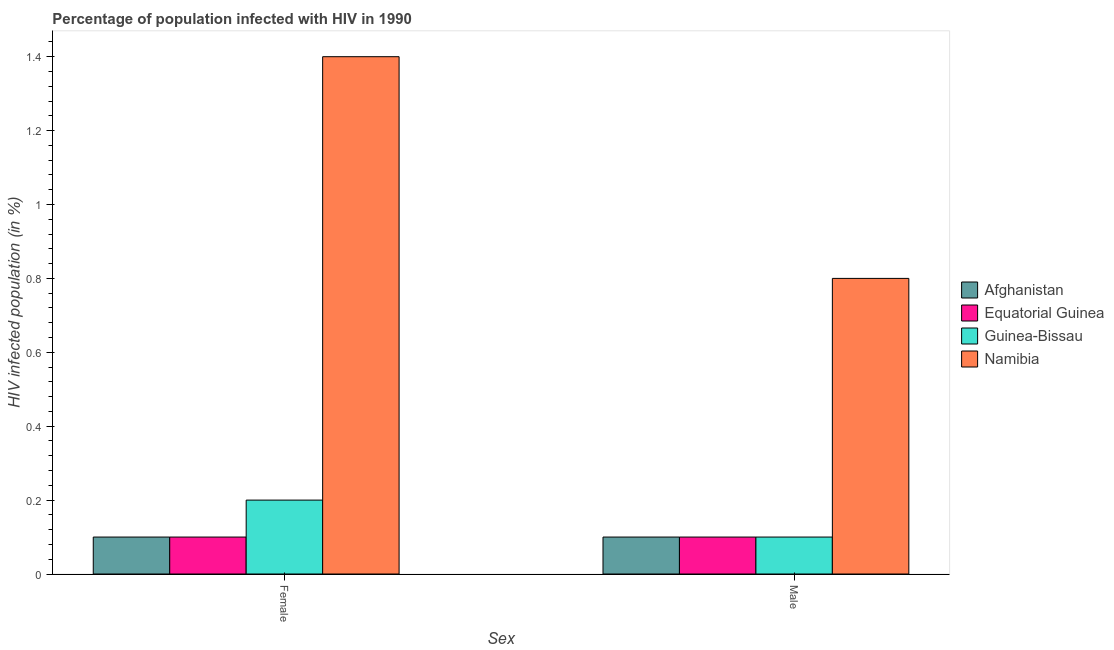How many groups of bars are there?
Offer a very short reply. 2. Are the number of bars per tick equal to the number of legend labels?
Make the answer very short. Yes. Are the number of bars on each tick of the X-axis equal?
Your answer should be compact. Yes. How many bars are there on the 2nd tick from the right?
Ensure brevity in your answer.  4. What is the label of the 1st group of bars from the left?
Keep it short and to the point. Female. What is the percentage of females who are infected with hiv in Guinea-Bissau?
Make the answer very short. 0.2. Across all countries, what is the minimum percentage of males who are infected with hiv?
Provide a short and direct response. 0.1. In which country was the percentage of females who are infected with hiv maximum?
Provide a succinct answer. Namibia. In which country was the percentage of males who are infected with hiv minimum?
Your response must be concise. Afghanistan. What is the total percentage of females who are infected with hiv in the graph?
Provide a short and direct response. 1.8. What is the difference between the percentage of males who are infected with hiv in Guinea-Bissau and that in Namibia?
Offer a terse response. -0.7. What is the average percentage of females who are infected with hiv per country?
Offer a terse response. 0.45. What is the difference between the percentage of females who are infected with hiv and percentage of males who are infected with hiv in Afghanistan?
Give a very brief answer. 0. What is the ratio of the percentage of females who are infected with hiv in Guinea-Bissau to that in Equatorial Guinea?
Your response must be concise. 2. Is the percentage of males who are infected with hiv in Guinea-Bissau less than that in Namibia?
Offer a very short reply. Yes. What does the 3rd bar from the left in Female represents?
Give a very brief answer. Guinea-Bissau. What does the 1st bar from the right in Female represents?
Give a very brief answer. Namibia. How many bars are there?
Ensure brevity in your answer.  8. Are all the bars in the graph horizontal?
Offer a terse response. No. How are the legend labels stacked?
Your response must be concise. Vertical. What is the title of the graph?
Provide a short and direct response. Percentage of population infected with HIV in 1990. What is the label or title of the X-axis?
Your answer should be very brief. Sex. What is the label or title of the Y-axis?
Ensure brevity in your answer.  HIV infected population (in %). What is the HIV infected population (in %) of Namibia in Female?
Offer a very short reply. 1.4. What is the HIV infected population (in %) of Afghanistan in Male?
Your answer should be very brief. 0.1. Across all Sex, what is the maximum HIV infected population (in %) in Afghanistan?
Your response must be concise. 0.1. Across all Sex, what is the maximum HIV infected population (in %) of Guinea-Bissau?
Offer a terse response. 0.2. Across all Sex, what is the minimum HIV infected population (in %) in Afghanistan?
Offer a very short reply. 0.1. Across all Sex, what is the minimum HIV infected population (in %) in Equatorial Guinea?
Offer a very short reply. 0.1. Across all Sex, what is the minimum HIV infected population (in %) in Guinea-Bissau?
Keep it short and to the point. 0.1. What is the total HIV infected population (in %) in Equatorial Guinea in the graph?
Make the answer very short. 0.2. What is the total HIV infected population (in %) of Namibia in the graph?
Keep it short and to the point. 2.2. What is the difference between the HIV infected population (in %) in Afghanistan in Female and the HIV infected population (in %) in Namibia in Male?
Offer a very short reply. -0.7. What is the difference between the HIV infected population (in %) in Guinea-Bissau in Female and the HIV infected population (in %) in Namibia in Male?
Provide a short and direct response. -0.6. What is the average HIV infected population (in %) in Guinea-Bissau per Sex?
Provide a succinct answer. 0.15. What is the difference between the HIV infected population (in %) of Afghanistan and HIV infected population (in %) of Equatorial Guinea in Female?
Provide a succinct answer. 0. What is the difference between the HIV infected population (in %) of Afghanistan and HIV infected population (in %) of Namibia in Female?
Give a very brief answer. -1.3. What is the difference between the HIV infected population (in %) of Equatorial Guinea and HIV infected population (in %) of Guinea-Bissau in Female?
Offer a very short reply. -0.1. What is the difference between the HIV infected population (in %) in Equatorial Guinea and HIV infected population (in %) in Namibia in Female?
Your answer should be compact. -1.3. What is the difference between the HIV infected population (in %) of Afghanistan and HIV infected population (in %) of Guinea-Bissau in Male?
Offer a terse response. 0. What is the difference between the HIV infected population (in %) of Equatorial Guinea and HIV infected population (in %) of Guinea-Bissau in Male?
Offer a very short reply. 0. What is the difference between the HIV infected population (in %) in Equatorial Guinea and HIV infected population (in %) in Namibia in Male?
Offer a very short reply. -0.7. What is the ratio of the HIV infected population (in %) of Afghanistan in Female to that in Male?
Your response must be concise. 1. What is the ratio of the HIV infected population (in %) in Equatorial Guinea in Female to that in Male?
Offer a very short reply. 1. What is the ratio of the HIV infected population (in %) in Namibia in Female to that in Male?
Offer a terse response. 1.75. What is the difference between the highest and the second highest HIV infected population (in %) in Afghanistan?
Ensure brevity in your answer.  0. What is the difference between the highest and the second highest HIV infected population (in %) in Guinea-Bissau?
Provide a succinct answer. 0.1. What is the difference between the highest and the lowest HIV infected population (in %) of Equatorial Guinea?
Keep it short and to the point. 0. 